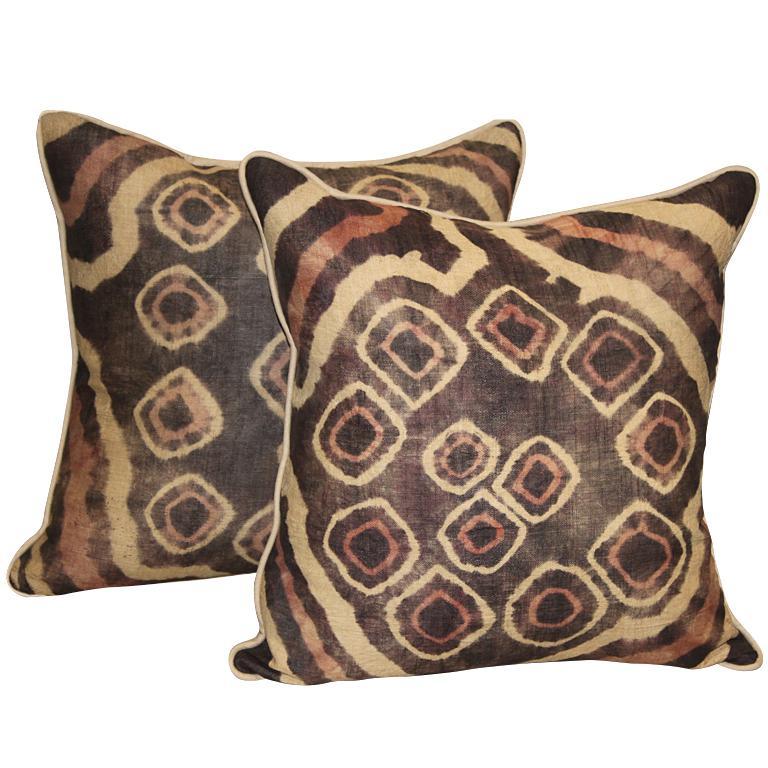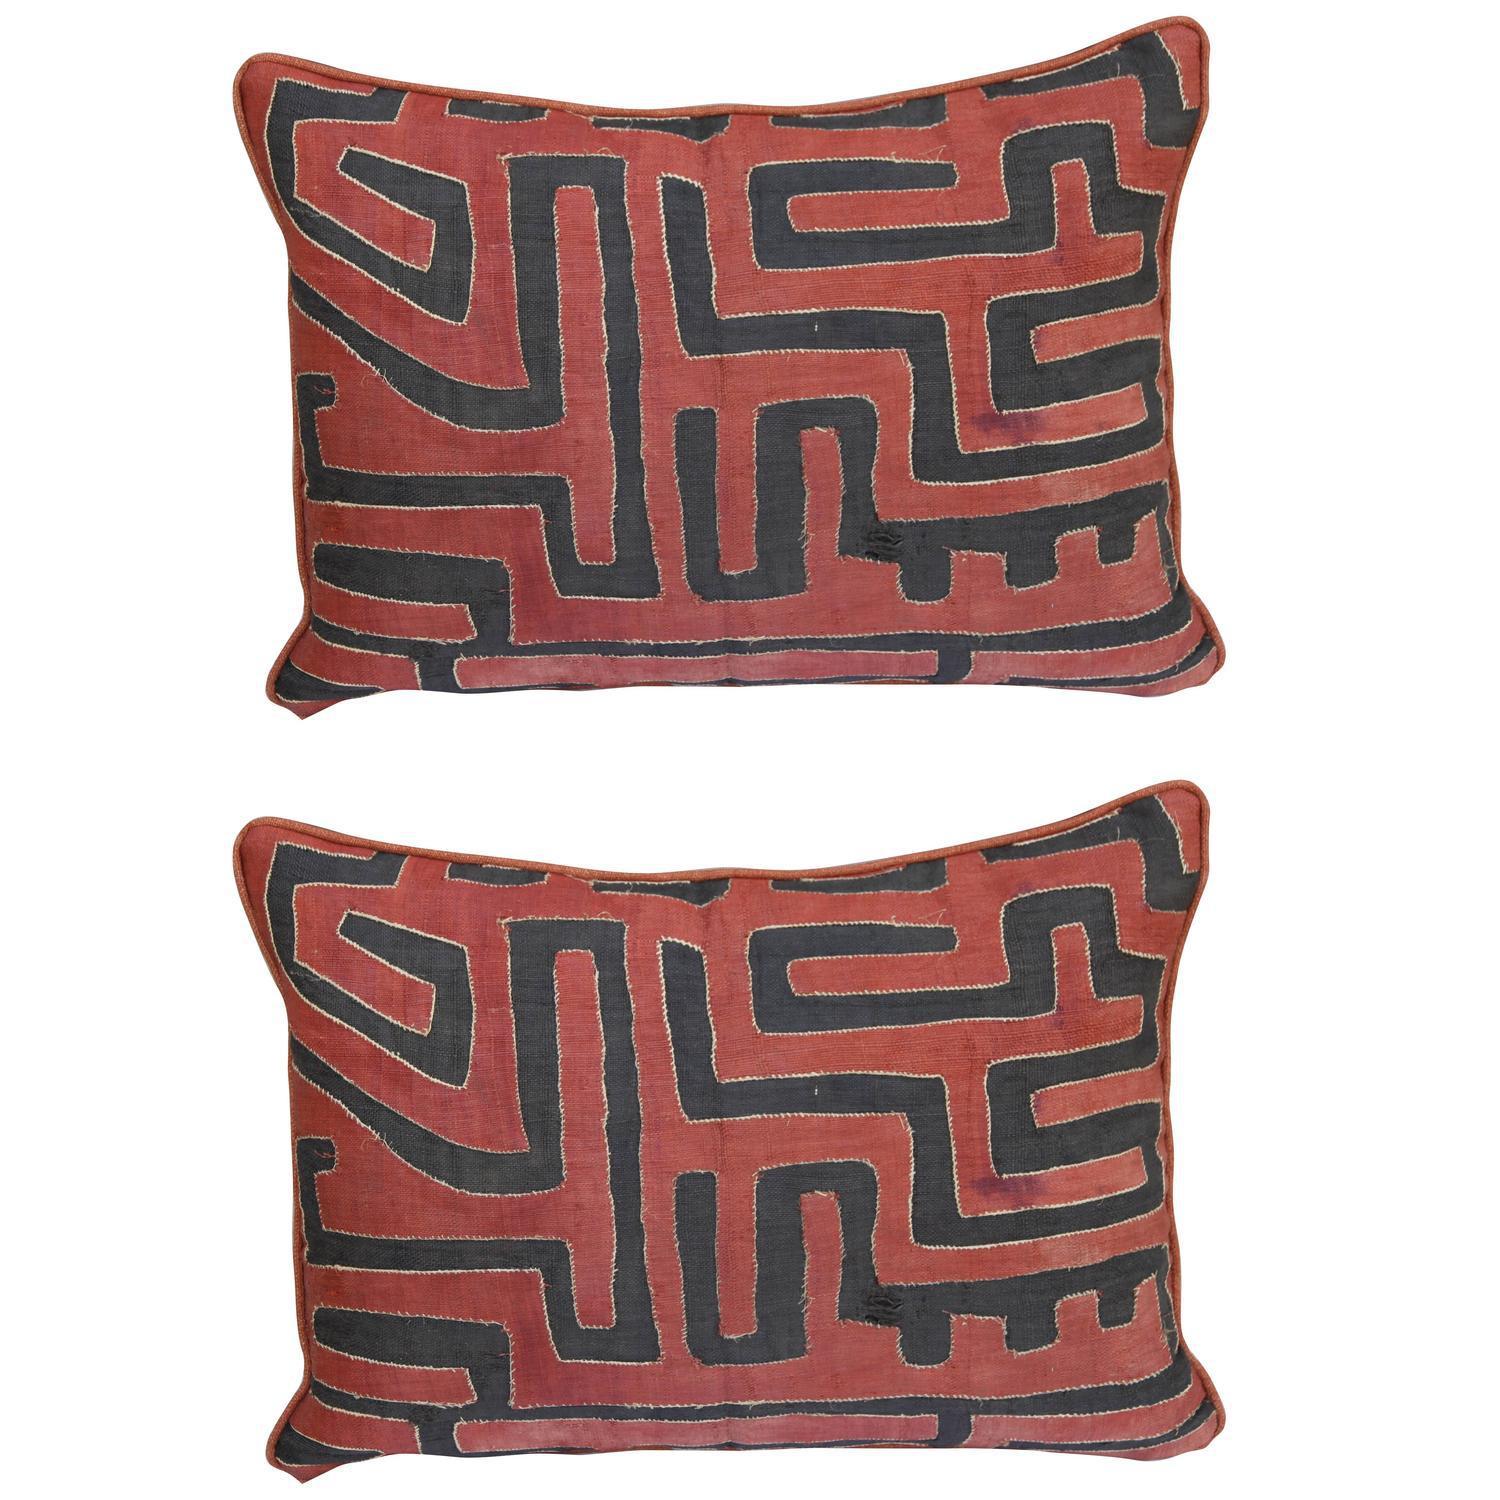The first image is the image on the left, the second image is the image on the right. Evaluate the accuracy of this statement regarding the images: "There are no more than two pillows in each image.". Is it true? Answer yes or no. Yes. 